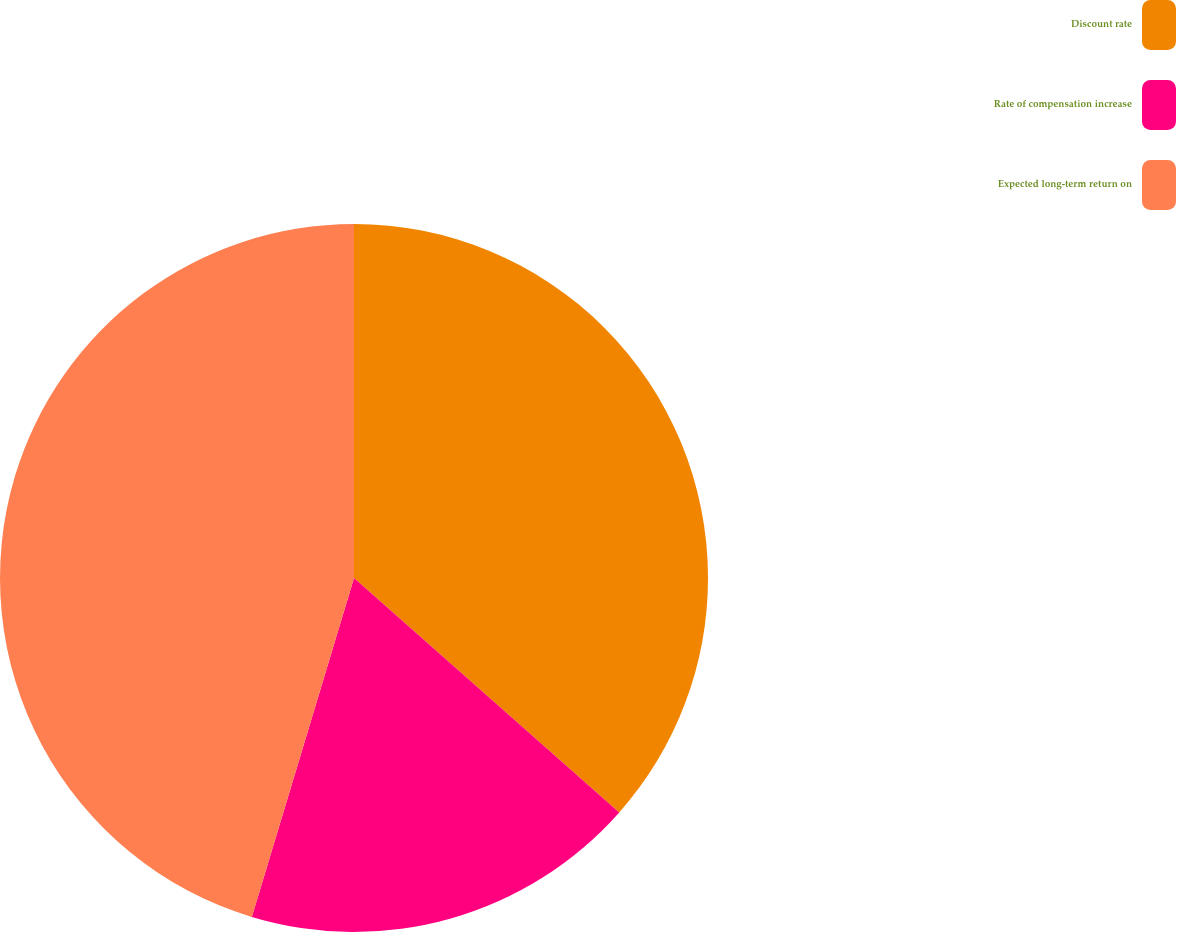<chart> <loc_0><loc_0><loc_500><loc_500><pie_chart><fcel>Discount rate<fcel>Rate of compensation increase<fcel>Expected long-term return on<nl><fcel>36.52%<fcel>18.14%<fcel>45.34%<nl></chart> 